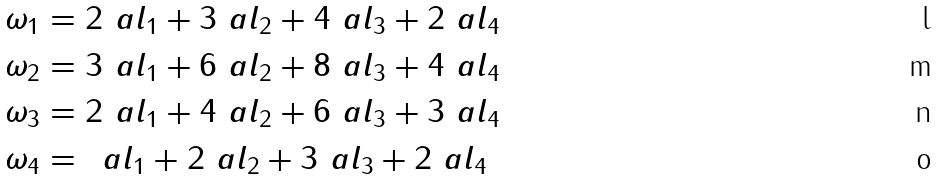Convert formula to latex. <formula><loc_0><loc_0><loc_500><loc_500>\omega _ { 1 } & = 2 \ a l _ { 1 } + 3 \ a l _ { 2 } + 4 \ a l _ { 3 } + 2 \ a l _ { 4 } \\ \omega _ { 2 } & = 3 \ a l _ { 1 } + 6 \ a l _ { 2 } + 8 \ a l _ { 3 } + 4 \ a l _ { 4 } \\ \omega _ { 3 } & = 2 \ a l _ { 1 } + 4 \ a l _ { 2 } + 6 \ a l _ { 3 } + 3 \ a l _ { 4 } \\ \omega _ { 4 } & = \, \ a l _ { 1 } + 2 \ a l _ { 2 } + 3 \ a l _ { 3 } + 2 \ a l _ { 4 }</formula> 